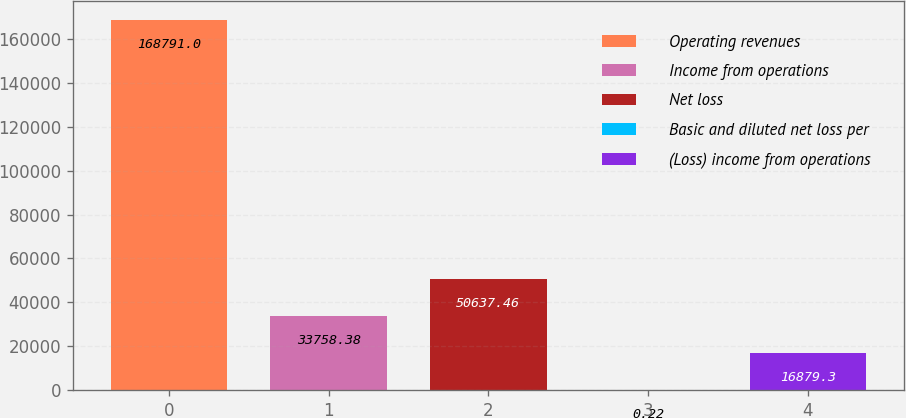Convert chart to OTSL. <chart><loc_0><loc_0><loc_500><loc_500><bar_chart><fcel>Operating revenues<fcel>Income from operations<fcel>Net loss<fcel>Basic and diluted net loss per<fcel>(Loss) income from operations<nl><fcel>168791<fcel>33758.4<fcel>50637.5<fcel>0.22<fcel>16879.3<nl></chart> 